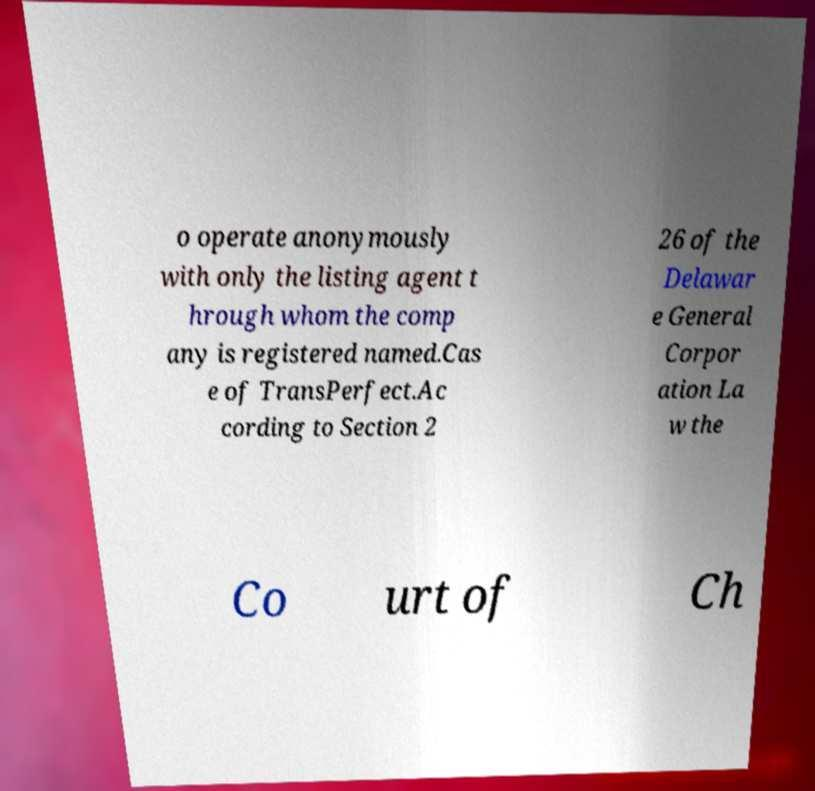For documentation purposes, I need the text within this image transcribed. Could you provide that? o operate anonymously with only the listing agent t hrough whom the comp any is registered named.Cas e of TransPerfect.Ac cording to Section 2 26 of the Delawar e General Corpor ation La w the Co urt of Ch 